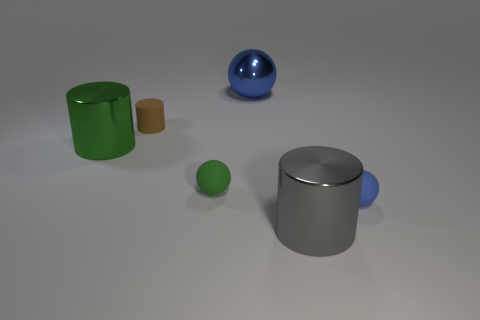What number of matte things are behind the large ball?
Ensure brevity in your answer.  0. What is the shape of the blue object that is on the left side of the shiny cylinder that is right of the small green object?
Give a very brief answer. Sphere. What is the shape of the green thing that is the same material as the large blue thing?
Make the answer very short. Cylinder. Is the size of the shiny object that is in front of the blue matte ball the same as the green thing that is on the right side of the big green metallic cylinder?
Make the answer very short. No. There is a green thing to the left of the brown matte cylinder; what shape is it?
Your answer should be very brief. Cylinder. What color is the metallic sphere?
Offer a very short reply. Blue. There is a blue matte thing; is its size the same as the metallic cylinder to the left of the tiny cylinder?
Your answer should be very brief. No. What number of metal things are tiny brown cylinders or yellow blocks?
Your response must be concise. 0. Does the large sphere have the same color as the tiny thing that is on the right side of the gray cylinder?
Your answer should be compact. Yes. What is the shape of the tiny brown rubber object?
Ensure brevity in your answer.  Cylinder. 